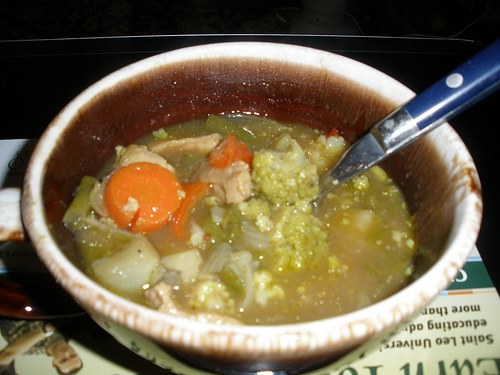Are there notepads or pizza slices? No, there are no notepads or pizza slices visible in the image. 